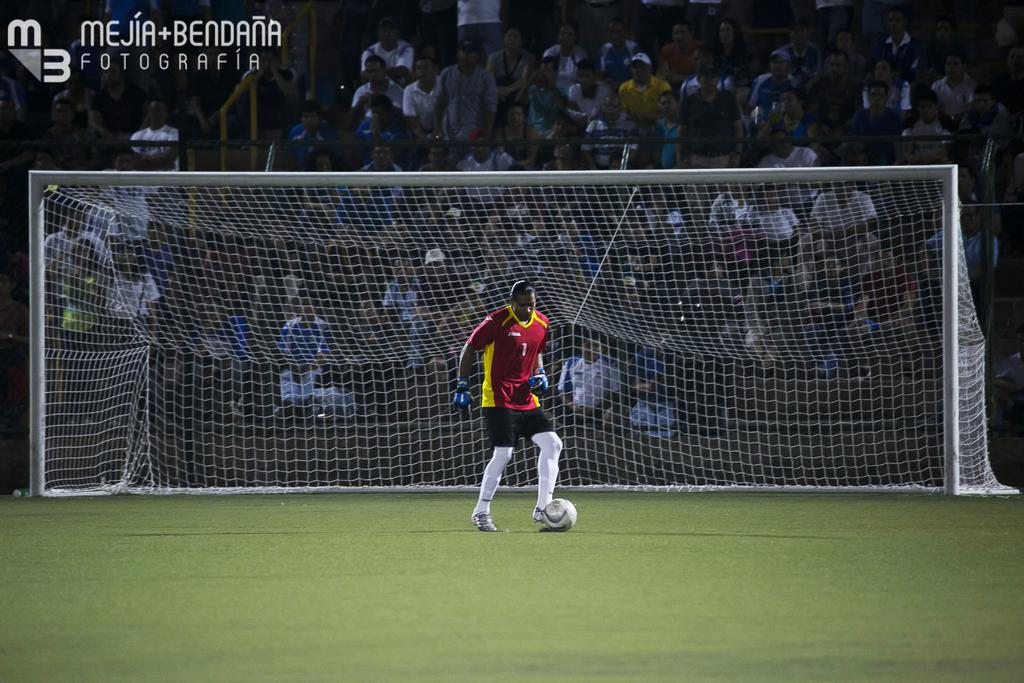What is the main subject in the center of the image? There is a sportsman in the center of the image. What is located at the bottom of the image? There is a wall at the bottom of the image. What is used to separate the two sides in the image? A net is visible in the image. What can be seen in the background of the image? There is a crowd sitting in the background of the image. Are there any words or letters in the image? Yes, text is present in the image. Can you tell me how many kittens are playing with the balls in the image? There are no kittens or balls present in the image. 